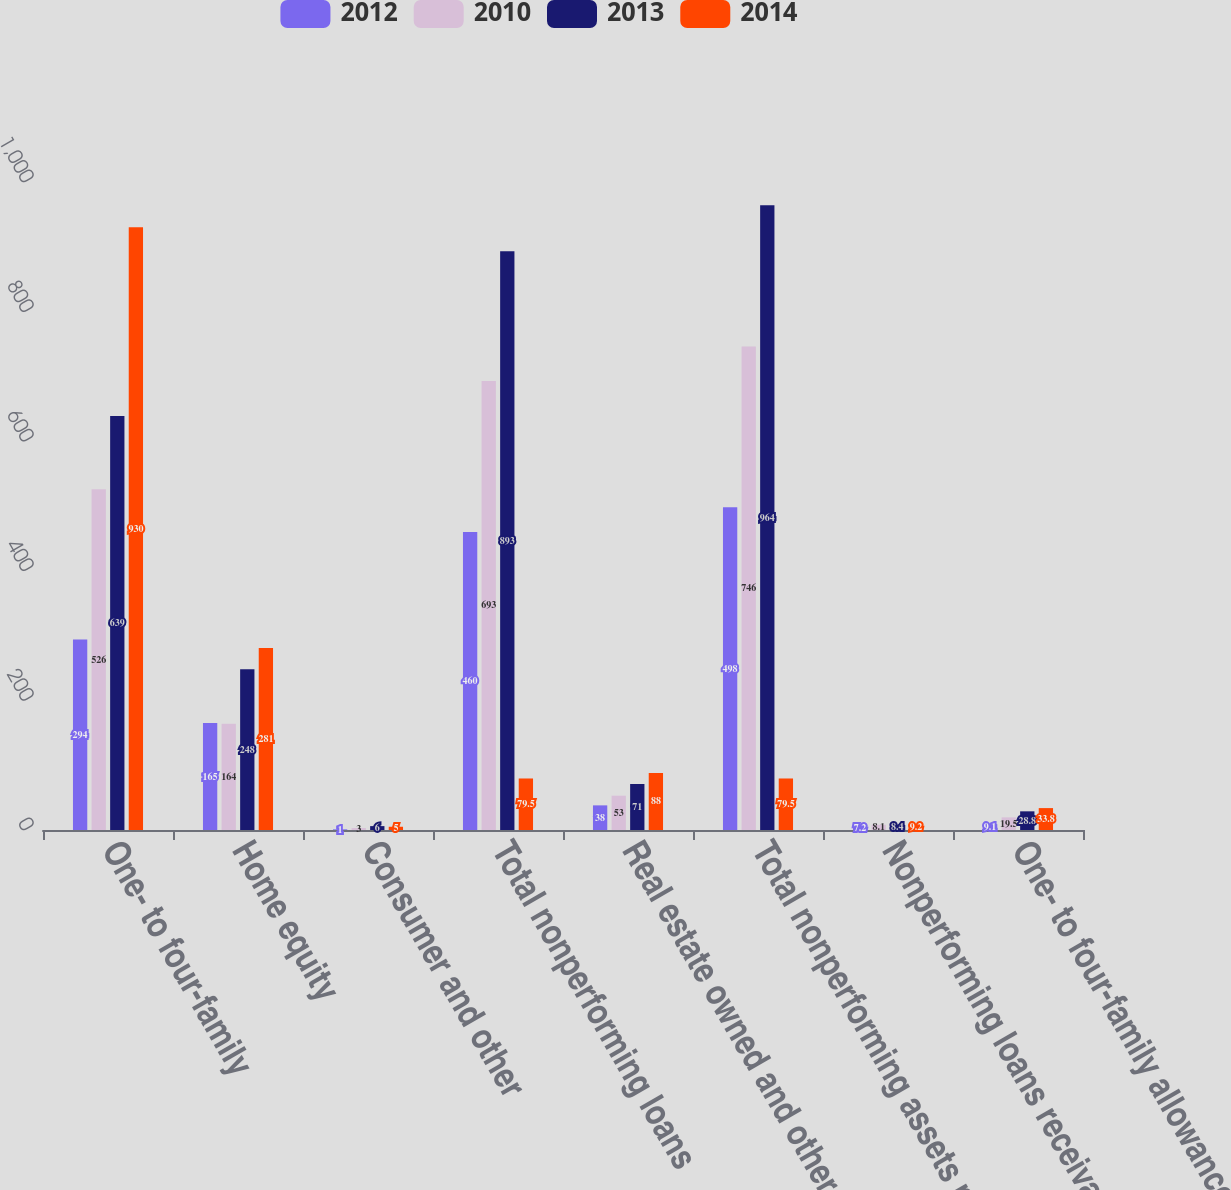<chart> <loc_0><loc_0><loc_500><loc_500><stacked_bar_chart><ecel><fcel>One- to four-family<fcel>Home equity<fcel>Consumer and other<fcel>Total nonperforming loans<fcel>Real estate owned and other<fcel>Total nonperforming assets net<fcel>Nonperforming loans receivable<fcel>One- to four-family allowance<nl><fcel>2012<fcel>294<fcel>165<fcel>1<fcel>460<fcel>38<fcel>498<fcel>7.2<fcel>9.1<nl><fcel>2010<fcel>526<fcel>164<fcel>3<fcel>693<fcel>53<fcel>746<fcel>8.1<fcel>19.5<nl><fcel>2013<fcel>639<fcel>248<fcel>6<fcel>893<fcel>71<fcel>964<fcel>8.4<fcel>28.8<nl><fcel>2014<fcel>930<fcel>281<fcel>5<fcel>79.5<fcel>88<fcel>79.5<fcel>9.2<fcel>33.8<nl></chart> 